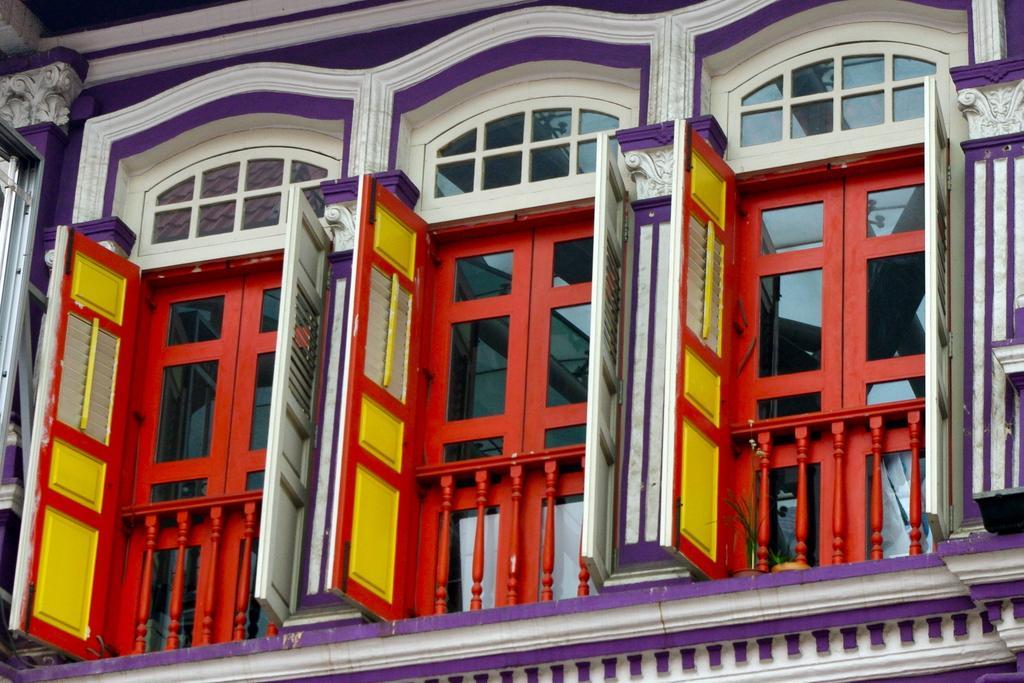In one or two sentences, can you explain what this image depicts? In this image we can see a building, there are some red color windows and the grille. 